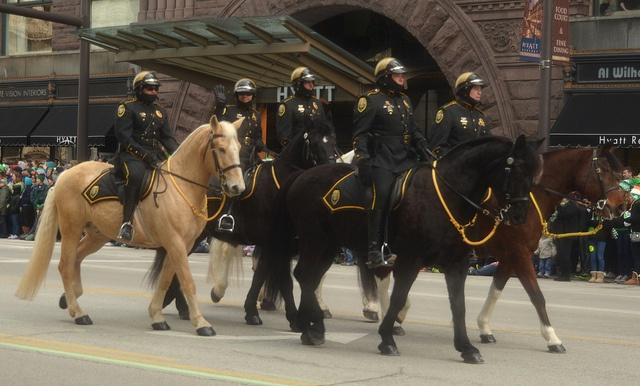Describe the objects in this image and their specific colors. I can see horse in gray and black tones, horse in gray, tan, brown, and olive tones, horse in brown, black, maroon, and gray tones, horse in gray and black tones, and people in gray, black, and maroon tones in this image. 